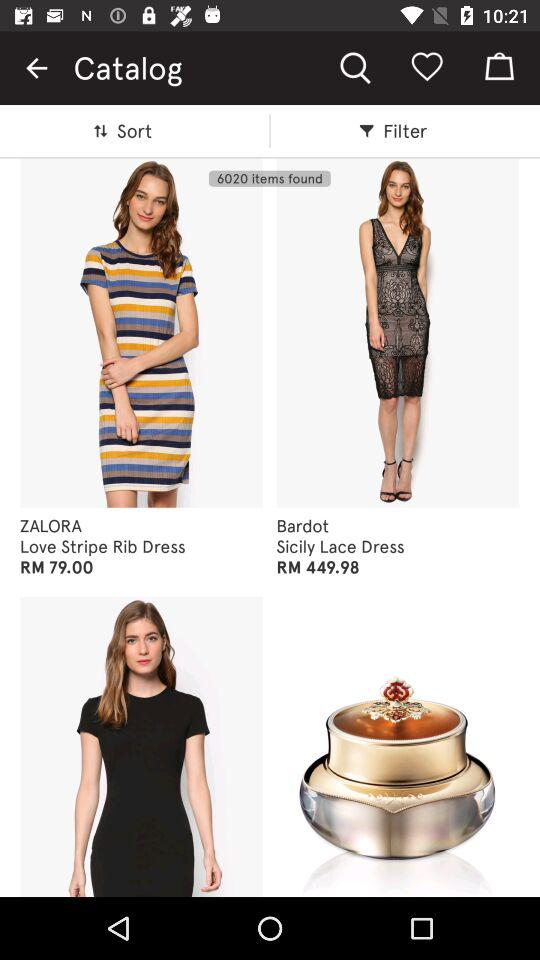How many total items have been found? There have been 6020 items found. 